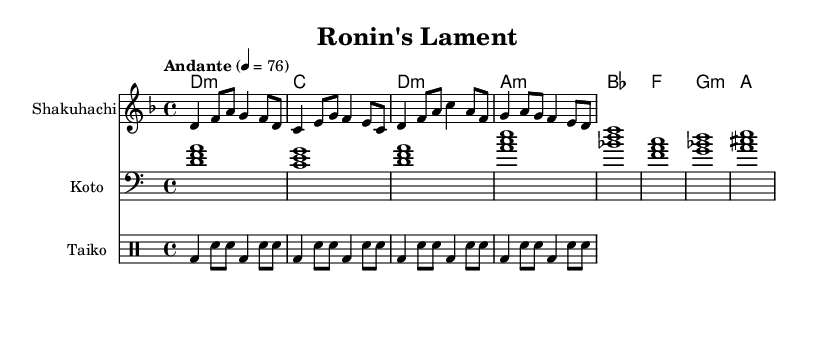What is the key signature of this music? The key signature is indicated by the 'd' note in the global section and there are no sharps or flats, which is characteristic of D minor.
Answer: D minor What is the time signature of this piece? The time signature is shown in the global section with the "4/4" indication, meaning each measure contains four beats, and each beat is a quarter note.
Answer: 4/4 What is the tempo marking for the piece? The tempo marking in the global section states "Andante" followed by "4 = 76," indicating a slow, moderate pace.
Answer: Andante How many measures are there in the melody? Counting the number of measures (noted through the vertical lines in the sheet music), there are four distinct measures in the melody.
Answer: Four What instrument plays the melody? The instrument line labeled as "Shakuhachi" indicates that this instrument is responsible for playing the melody throughout the piece.
Answer: Shakuhachi What type of musical piece is this based on its cultural context? Given the title "Ronin's Lament" and the instrumentation featuring traditional Japanese instruments, it can be classified as a traditional Japanese folk music piece.
Answer: Traditional Japanese folk music What instrument accompanies the melody? The second staff is labeled "Koto," which signifies that this instrument provides harmonic support to the melody.
Answer: Koto 